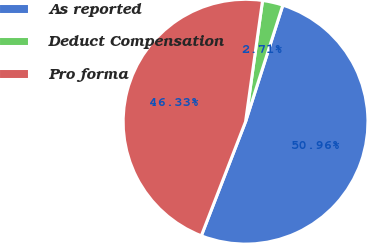Convert chart. <chart><loc_0><loc_0><loc_500><loc_500><pie_chart><fcel>As reported<fcel>Deduct Compensation<fcel>Pro forma<nl><fcel>50.96%<fcel>2.71%<fcel>46.33%<nl></chart> 